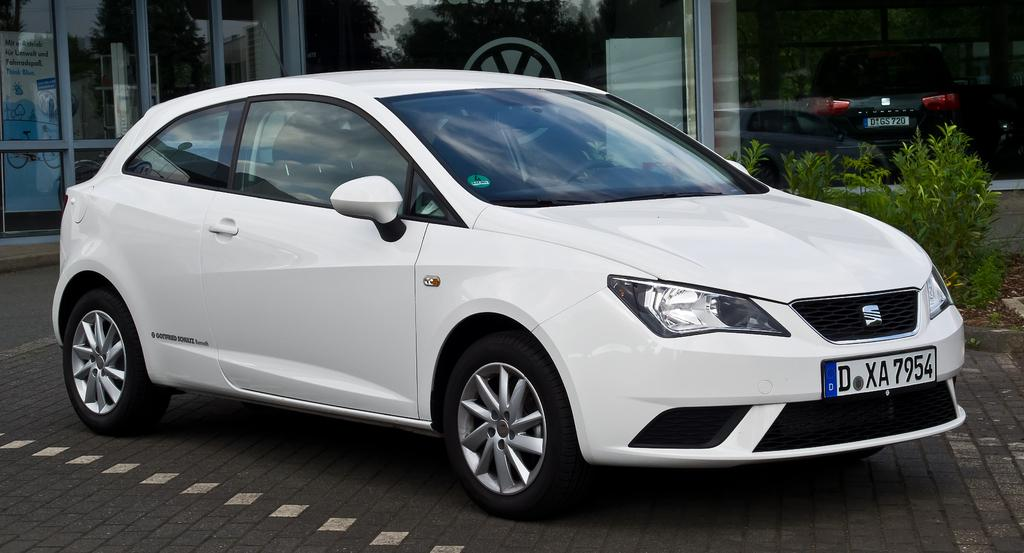What is on the road in the image? There is a car on the road in the image. What type of vegetation can be seen in the image? There are plants in the image. What architectural feature is present in the image? There are glass doors in the image. What is inside the glass doors? There is a vehicle and a banner inside the glass doors. What can be seen through the glass doors? There is a reflection of trees visible through the glass doors. What type of knife is being used to mix the eggnog in the image? There is no knife or eggnog present in the image. What type of agreement is being signed in the image? There is no agreement or signing activity present in the image. 